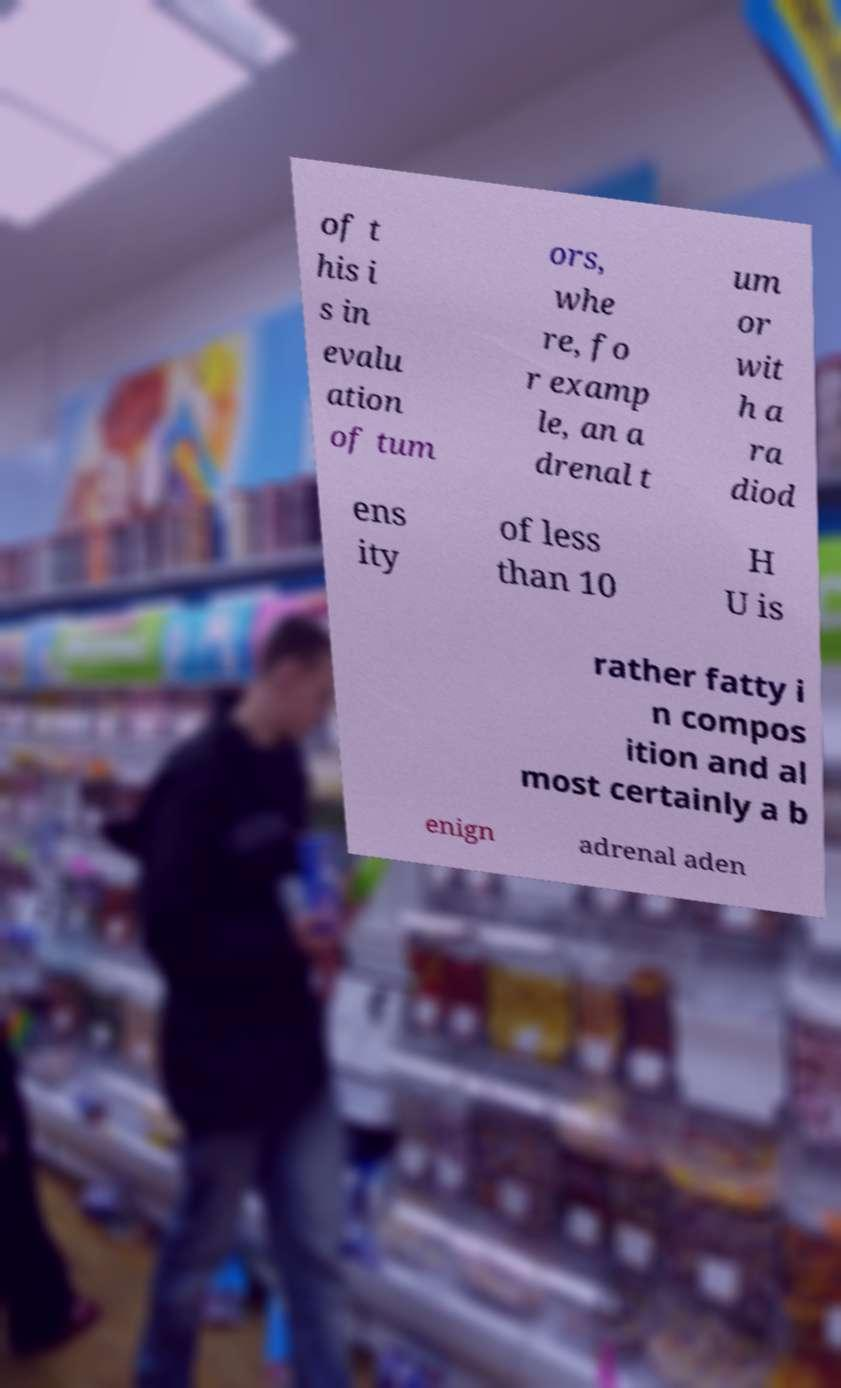I need the written content from this picture converted into text. Can you do that? of t his i s in evalu ation of tum ors, whe re, fo r examp le, an a drenal t um or wit h a ra diod ens ity of less than 10 H U is rather fatty i n compos ition and al most certainly a b enign adrenal aden 